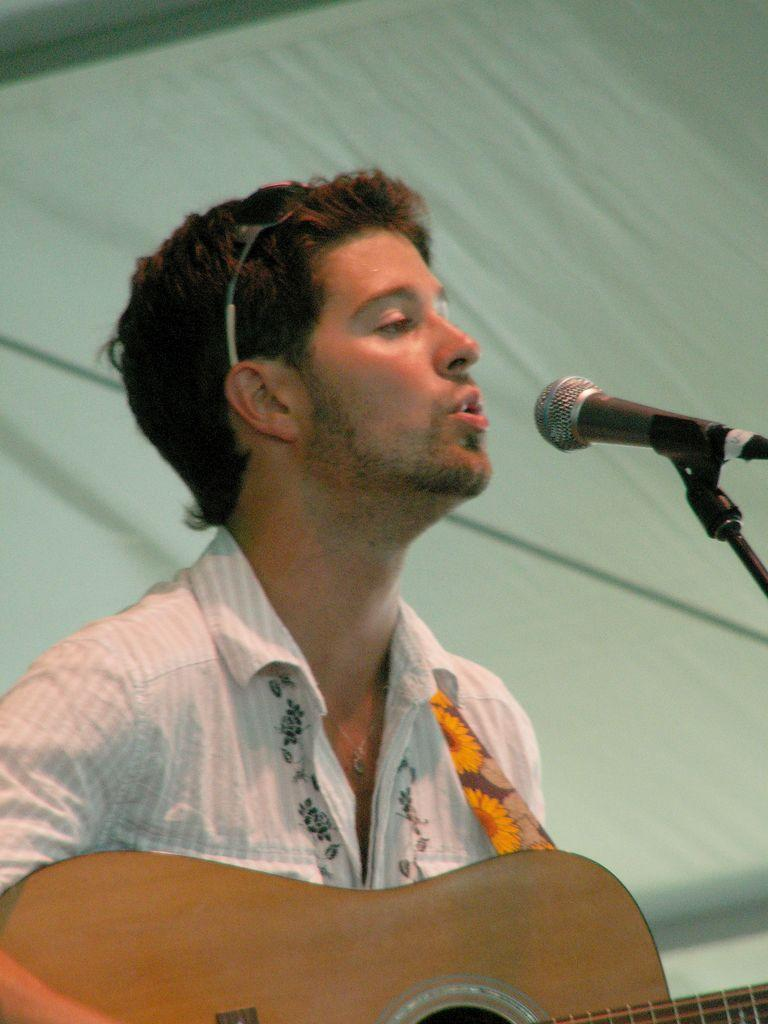What is the man in the image doing? The man in the image is talking in the microphone. Can you describe the other man in the image? The other man is wearing a white shirt and holding a guitar. What can be seen in the background of the image? There is a white curtain in the background. Is the man driving a car in the image? No, there is no car or driving activity present in the image. How many chairs can be seen in the image? There are no chairs visible in the image. 